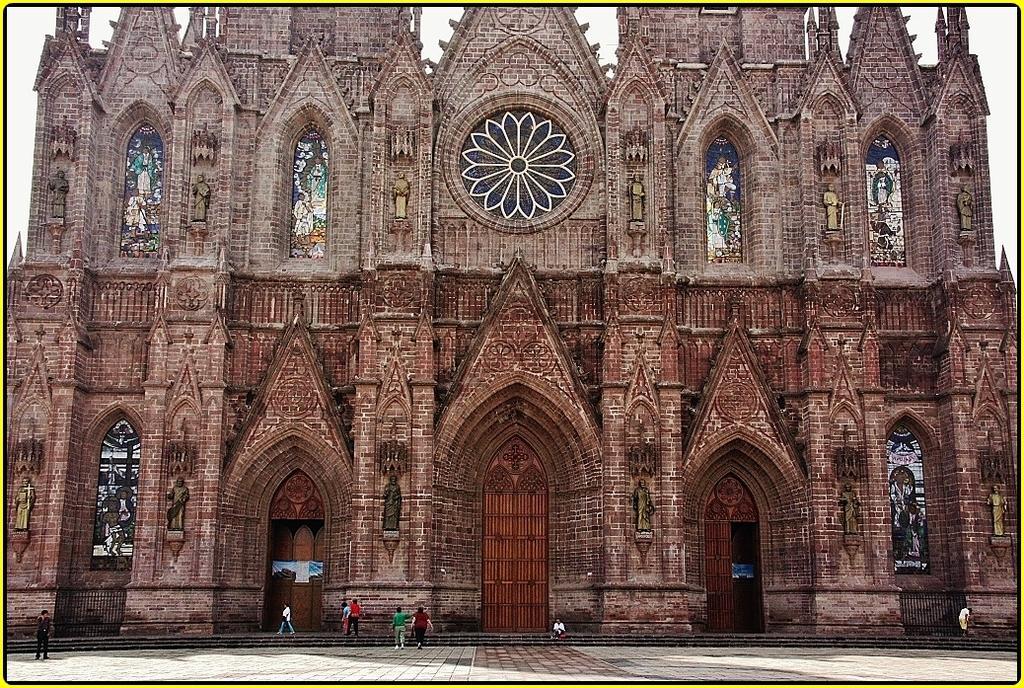In one or two sentences, can you explain what this image depicts? In this image we can see building, persons sitting on the floor and some are standing on the floor. In the background there is sky. 